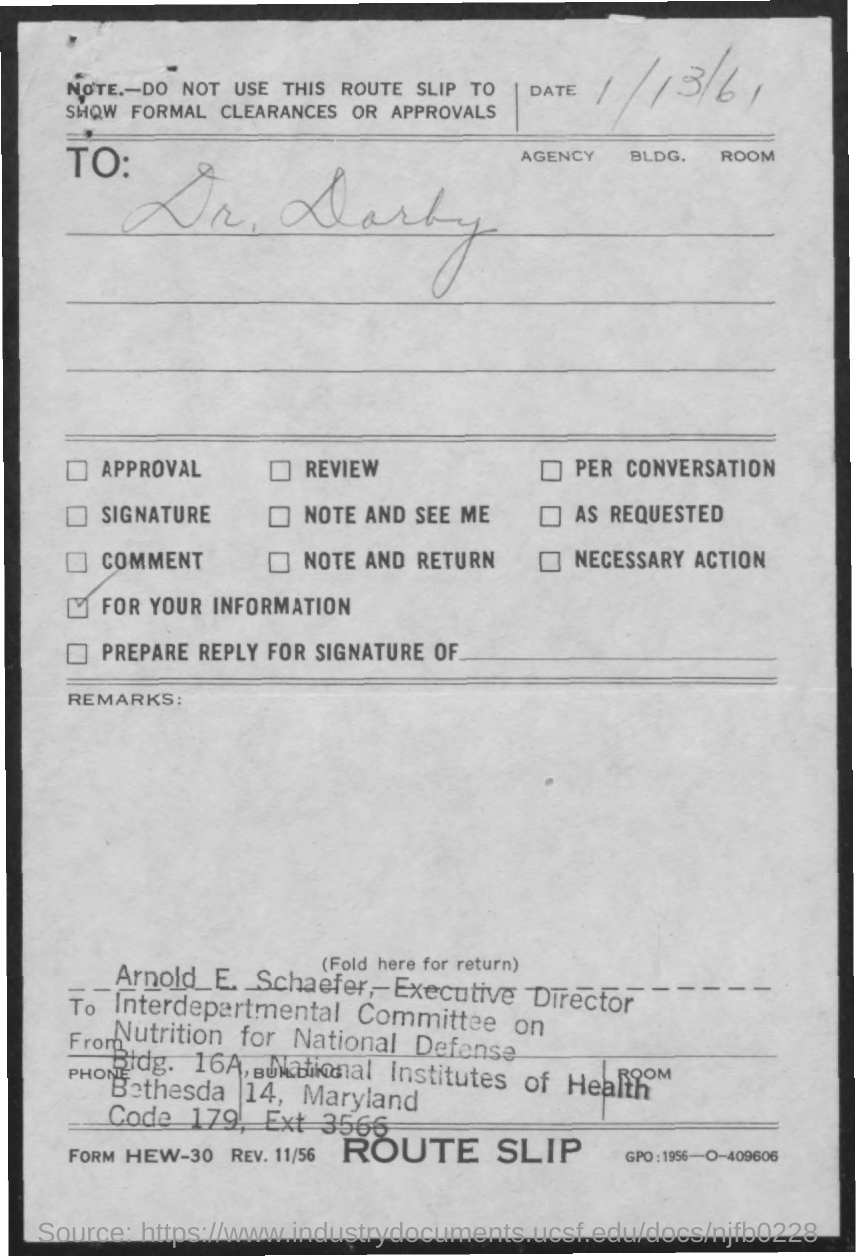Who is the Executive Director of the Interdepartmental Committee on Nutrition for National Defense?
Ensure brevity in your answer.  Arnold E. Schaefer. What is the date mentioned in the document?
Provide a succinct answer. 1/13/61. 